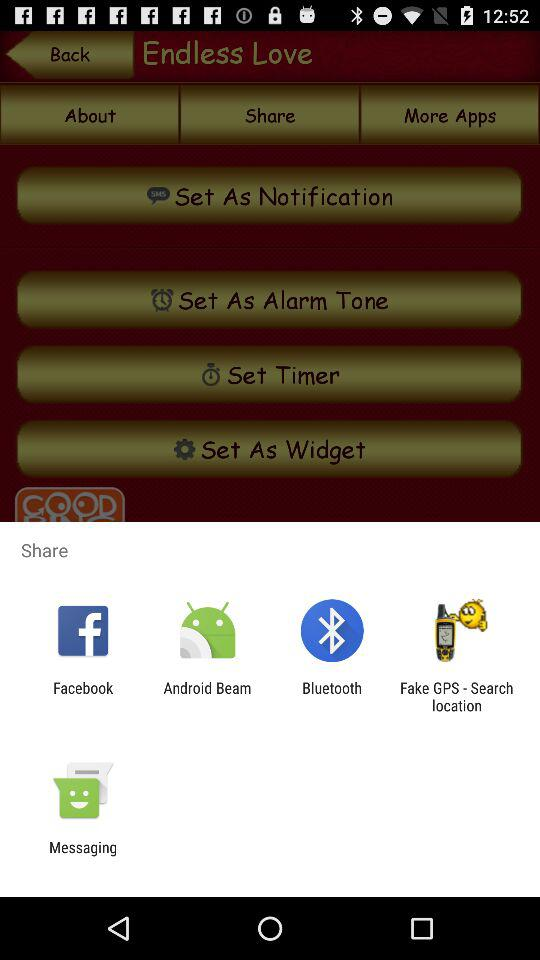What accounts can I use to share? You can use "Facebook", "Android Beam", "Bluetooth", "Fake GPS - Search location" and "Messaging" accounts to share. 